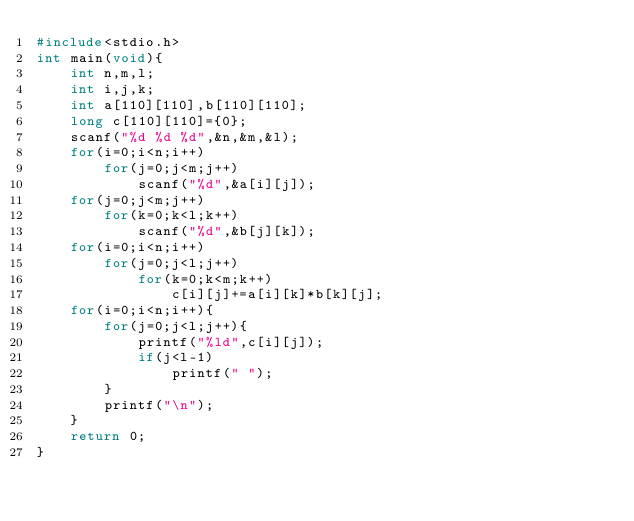Convert code to text. <code><loc_0><loc_0><loc_500><loc_500><_C_>#include<stdio.h>
int main(void){
    int n,m,l;
    int i,j,k;
    int a[110][110],b[110][110];
    long c[110][110]={0};
    scanf("%d %d %d",&n,&m,&l);
    for(i=0;i<n;i++)
        for(j=0;j<m;j++)
            scanf("%d",&a[i][j]);
    for(j=0;j<m;j++)
        for(k=0;k<l;k++)
            scanf("%d",&b[j][k]);
    for(i=0;i<n;i++)
        for(j=0;j<l;j++)
            for(k=0;k<m;k++)
                c[i][j]+=a[i][k]*b[k][j];
    for(i=0;i<n;i++){
        for(j=0;j<l;j++){
            printf("%ld",c[i][j]);
            if(j<l-1)
                printf(" ");
        }
        printf("\n");
    }
    return 0;
}</code> 